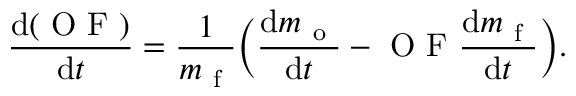<formula> <loc_0><loc_0><loc_500><loc_500>\frac { d ( O F ) } { d t } = \frac { 1 } { m _ { f } } \left ( \frac { d m _ { o } } { d t } - O F \frac { d m _ { f } } { d t } \right ) .</formula> 